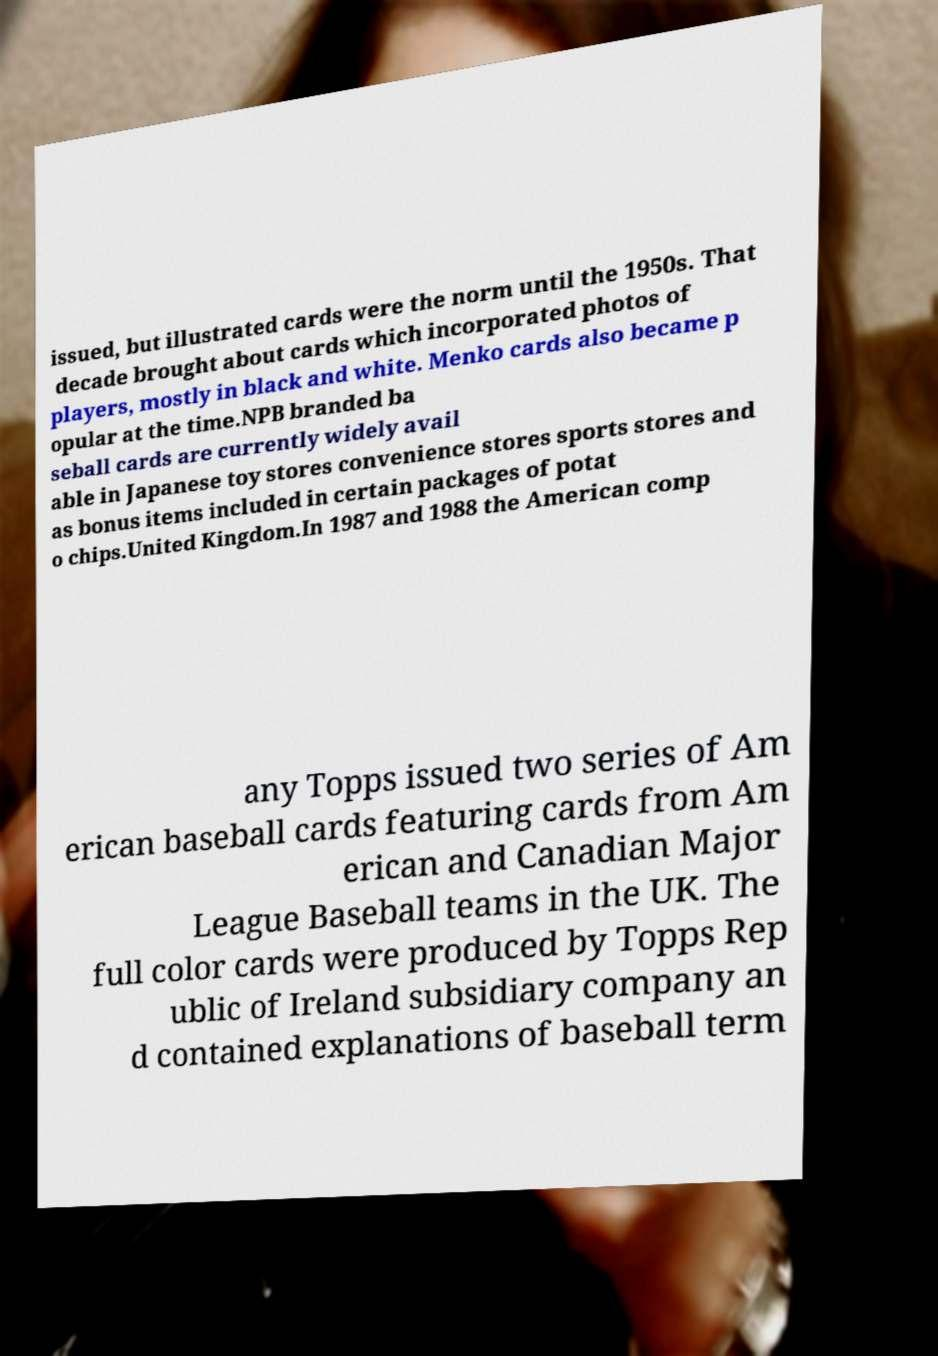There's text embedded in this image that I need extracted. Can you transcribe it verbatim? issued, but illustrated cards were the norm until the 1950s. That decade brought about cards which incorporated photos of players, mostly in black and white. Menko cards also became p opular at the time.NPB branded ba seball cards are currently widely avail able in Japanese toy stores convenience stores sports stores and as bonus items included in certain packages of potat o chips.United Kingdom.In 1987 and 1988 the American comp any Topps issued two series of Am erican baseball cards featuring cards from Am erican and Canadian Major League Baseball teams in the UK. The full color cards were produced by Topps Rep ublic of Ireland subsidiary company an d contained explanations of baseball term 